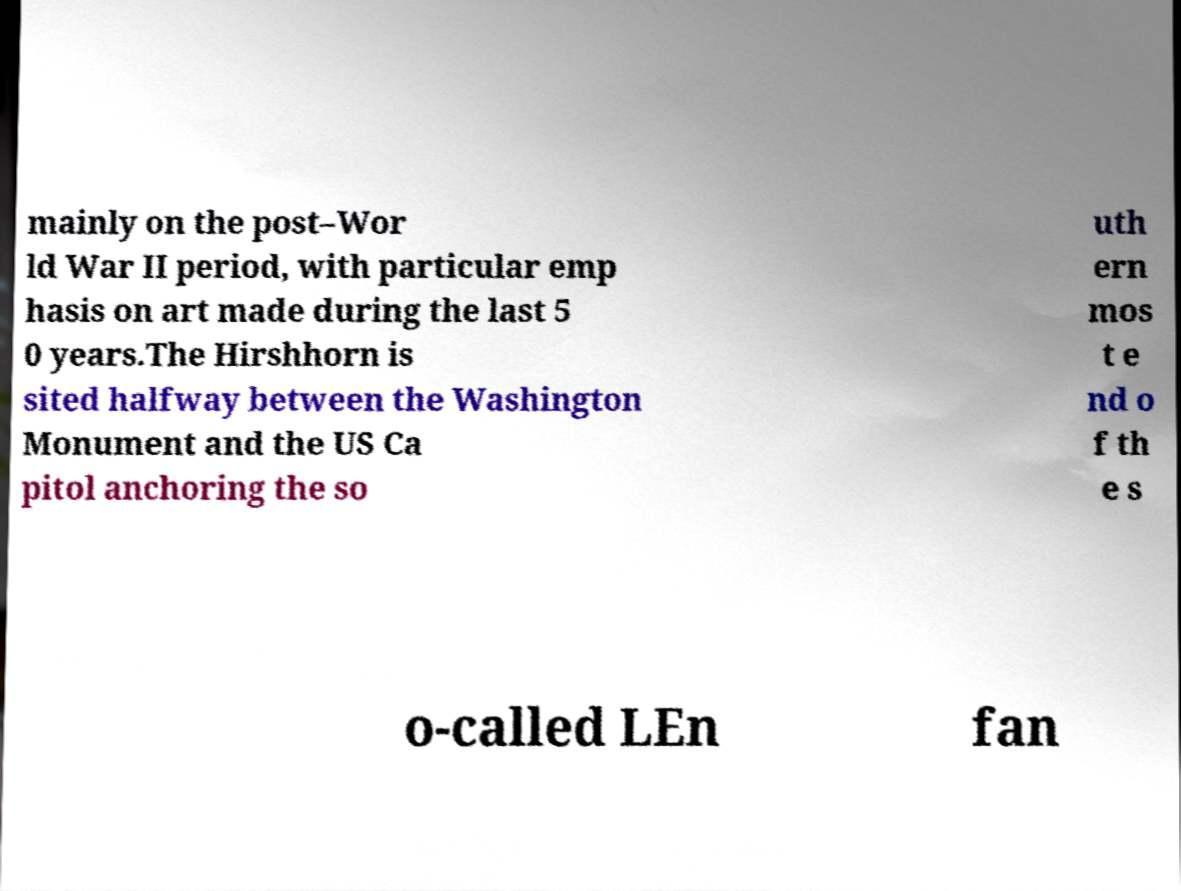Could you extract and type out the text from this image? mainly on the post–Wor ld War II period, with particular emp hasis on art made during the last 5 0 years.The Hirshhorn is sited halfway between the Washington Monument and the US Ca pitol anchoring the so uth ern mos t e nd o f th e s o-called LEn fan 